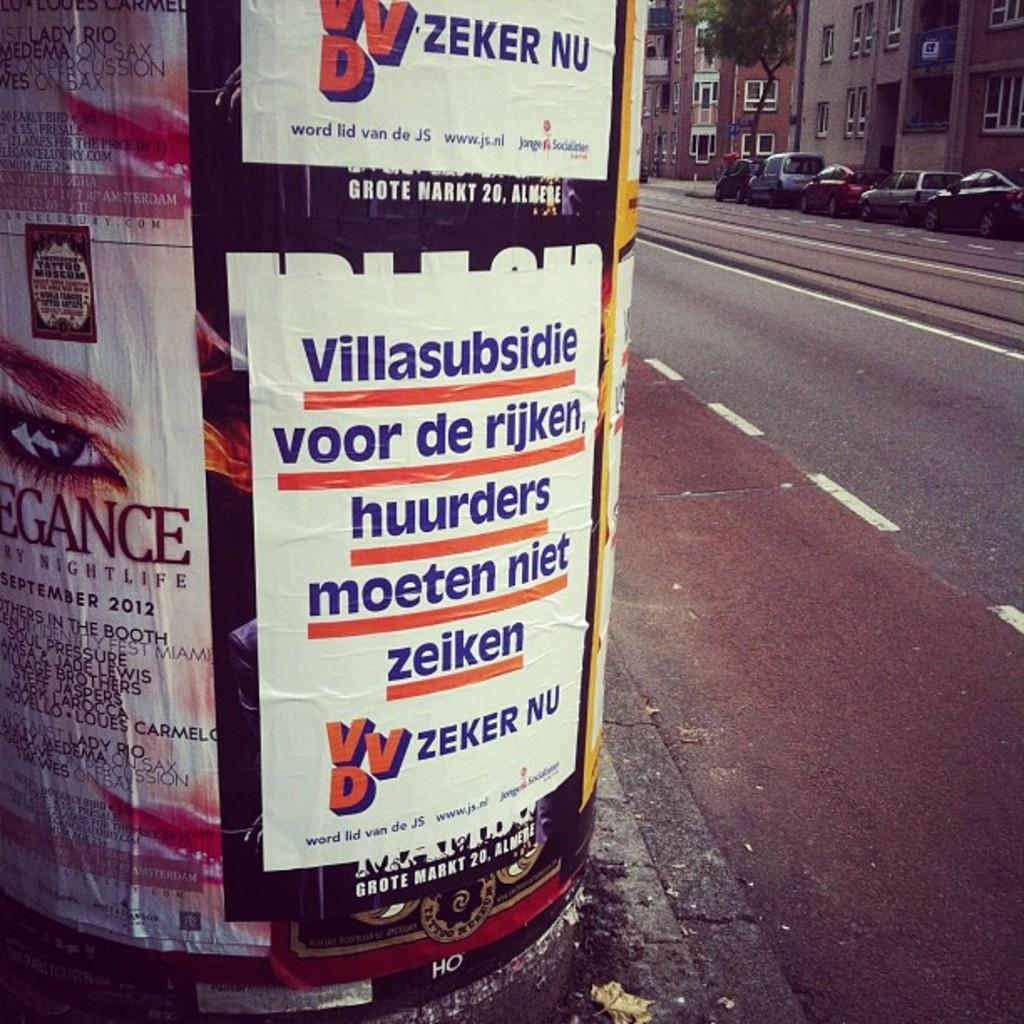<image>
Render a clear and concise summary of the photo. Posters with VVD logo for Zeker Nu on a big pole. 